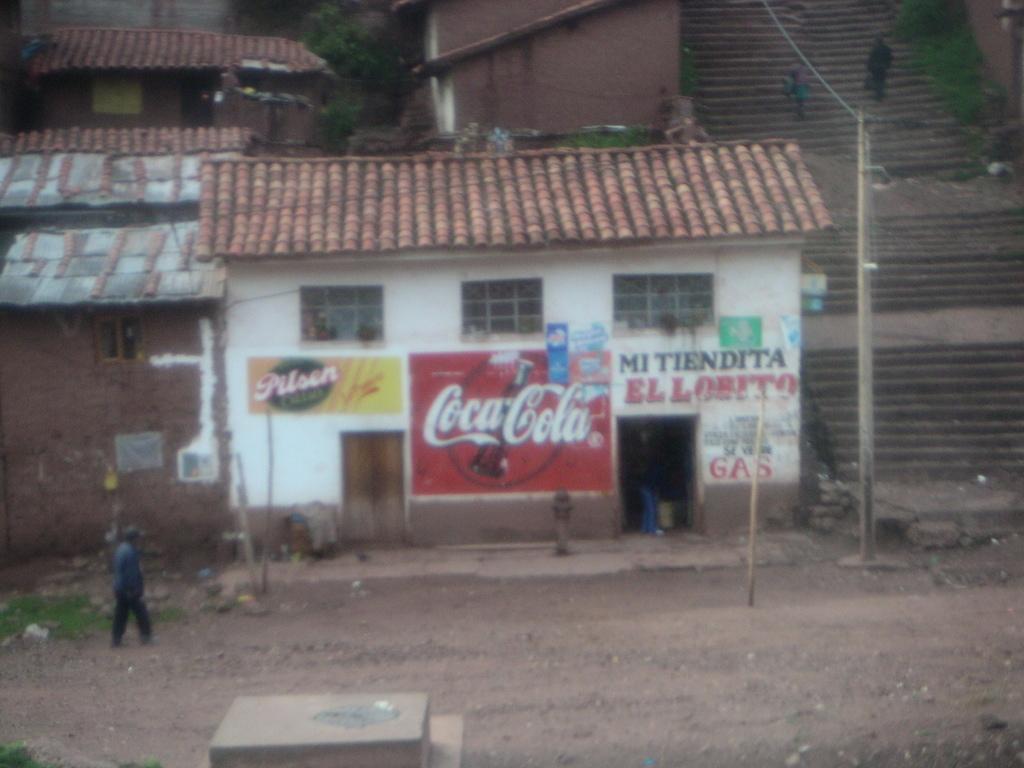Can you describe this image briefly? In this image I can see a box in the front. A person is walking and there are houses at the back. There is a pole and stairs on the right. A person is standing on the stairs and there is a plant. 